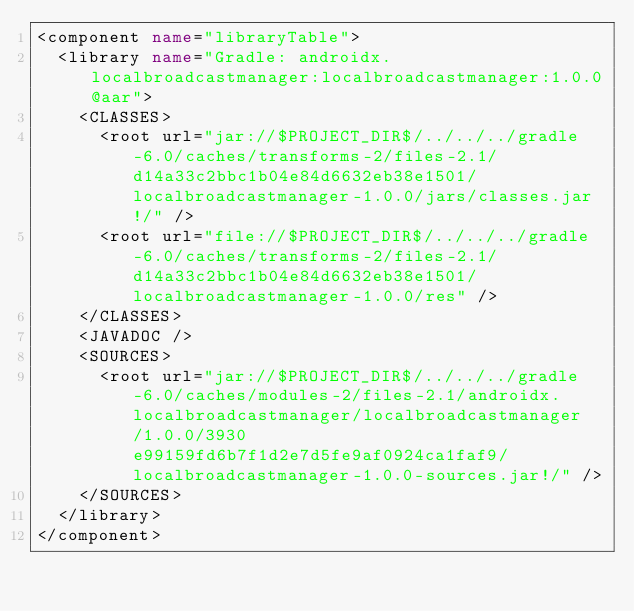Convert code to text. <code><loc_0><loc_0><loc_500><loc_500><_XML_><component name="libraryTable">
  <library name="Gradle: androidx.localbroadcastmanager:localbroadcastmanager:1.0.0@aar">
    <CLASSES>
      <root url="jar://$PROJECT_DIR$/../../../gradle-6.0/caches/transforms-2/files-2.1/d14a33c2bbc1b04e84d6632eb38e1501/localbroadcastmanager-1.0.0/jars/classes.jar!/" />
      <root url="file://$PROJECT_DIR$/../../../gradle-6.0/caches/transforms-2/files-2.1/d14a33c2bbc1b04e84d6632eb38e1501/localbroadcastmanager-1.0.0/res" />
    </CLASSES>
    <JAVADOC />
    <SOURCES>
      <root url="jar://$PROJECT_DIR$/../../../gradle-6.0/caches/modules-2/files-2.1/androidx.localbroadcastmanager/localbroadcastmanager/1.0.0/3930e99159fd6b7f1d2e7d5fe9af0924ca1faf9/localbroadcastmanager-1.0.0-sources.jar!/" />
    </SOURCES>
  </library>
</component></code> 